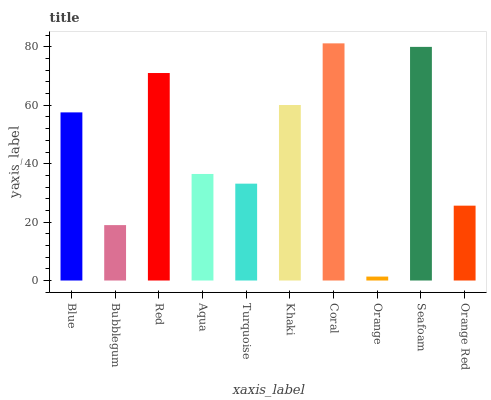Is Orange the minimum?
Answer yes or no. Yes. Is Coral the maximum?
Answer yes or no. Yes. Is Bubblegum the minimum?
Answer yes or no. No. Is Bubblegum the maximum?
Answer yes or no. No. Is Blue greater than Bubblegum?
Answer yes or no. Yes. Is Bubblegum less than Blue?
Answer yes or no. Yes. Is Bubblegum greater than Blue?
Answer yes or no. No. Is Blue less than Bubblegum?
Answer yes or no. No. Is Blue the high median?
Answer yes or no. Yes. Is Aqua the low median?
Answer yes or no. Yes. Is Seafoam the high median?
Answer yes or no. No. Is Bubblegum the low median?
Answer yes or no. No. 